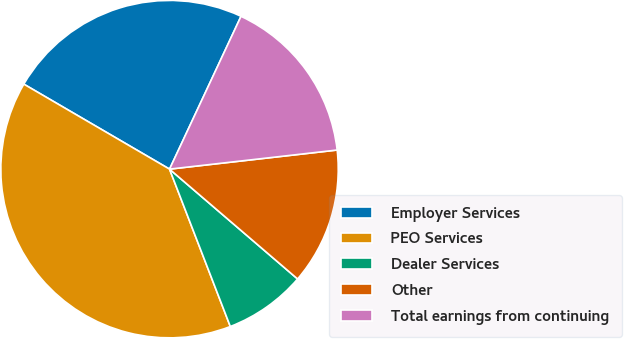<chart> <loc_0><loc_0><loc_500><loc_500><pie_chart><fcel>Employer Services<fcel>PEO Services<fcel>Dealer Services<fcel>Other<fcel>Total earnings from continuing<nl><fcel>23.56%<fcel>39.27%<fcel>7.85%<fcel>13.09%<fcel>16.23%<nl></chart> 